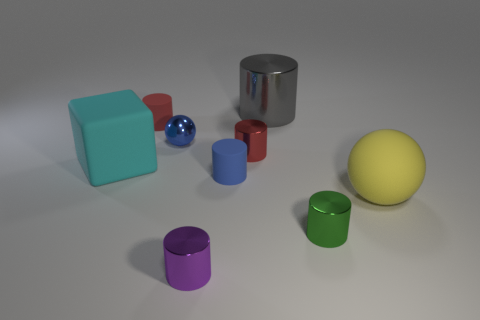Subtract all blue cylinders. How many cylinders are left? 5 Subtract all cyan spheres. How many red cylinders are left? 2 Subtract all gray cylinders. How many cylinders are left? 5 Subtract all blocks. How many objects are left? 8 Subtract 1 cylinders. How many cylinders are left? 5 Subtract all red spheres. Subtract all yellow cubes. How many spheres are left? 2 Subtract all tiny metallic balls. Subtract all small red matte cylinders. How many objects are left? 7 Add 2 small red cylinders. How many small red cylinders are left? 4 Add 9 large blue balls. How many large blue balls exist? 9 Subtract 0 cyan cylinders. How many objects are left? 9 